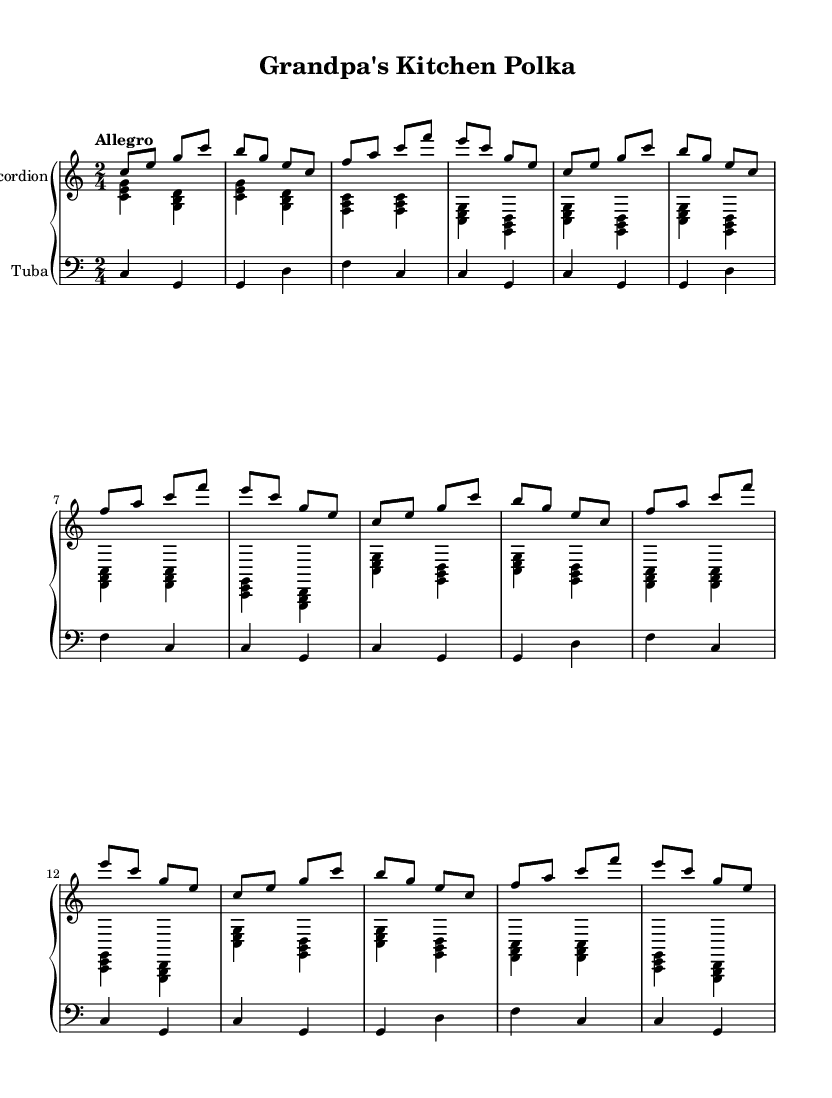What is the key signature of this music? The key signature is C major, which has no sharps or flats.
Answer: C major What is the time signature of this piece? The time signature, indicated at the beginning of the music, is 2/4, meaning there are two beats in a measure.
Answer: 2/4 What is the tempo marking for this music? The tempo marking is "Allegro," suggesting a fast and lively pace.
Answer: Allegro How many measures are there in the accordion right part before it repeats? The accordion right part consists of 4 measures before the section repeats for another 3 times (totaling 12 measures).
Answer: 4 How many voices are in the accordion staff? There are two voices in the accordion staff: one for the right hand and another for the left hand.
Answer: 2 What is the main instrument accompaniment for the bass line in this piece? The main bass instrument in this sheet music is the tuba, indicated in the bass clef.
Answer: Tuba What indicates that this piece is a lively dance? The combination of the tempo marking “Allegro” and the upbeat feel of the polka rhythm gives it the characteristic liveliness associated with dance music.
Answer: Allegro 